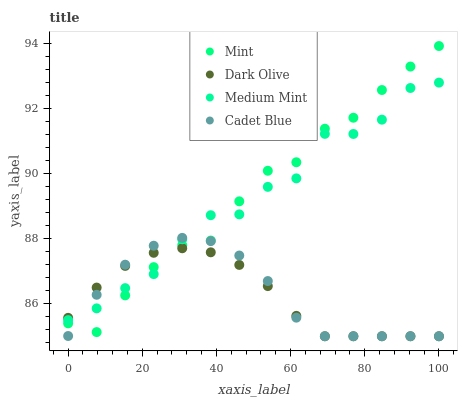Does Dark Olive have the minimum area under the curve?
Answer yes or no. Yes. Does Mint have the maximum area under the curve?
Answer yes or no. Yes. Does Mint have the minimum area under the curve?
Answer yes or no. No. Does Dark Olive have the maximum area under the curve?
Answer yes or no. No. Is Dark Olive the smoothest?
Answer yes or no. Yes. Is Medium Mint the roughest?
Answer yes or no. Yes. Is Mint the smoothest?
Answer yes or no. No. Is Mint the roughest?
Answer yes or no. No. Does Dark Olive have the lowest value?
Answer yes or no. Yes. Does Mint have the lowest value?
Answer yes or no. No. Does Mint have the highest value?
Answer yes or no. Yes. Does Dark Olive have the highest value?
Answer yes or no. No. Does Mint intersect Dark Olive?
Answer yes or no. Yes. Is Mint less than Dark Olive?
Answer yes or no. No. Is Mint greater than Dark Olive?
Answer yes or no. No. 